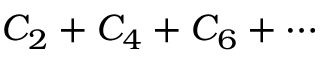<formula> <loc_0><loc_0><loc_500><loc_500>C _ { 2 } + C _ { 4 } + C _ { 6 } + \cdots</formula> 